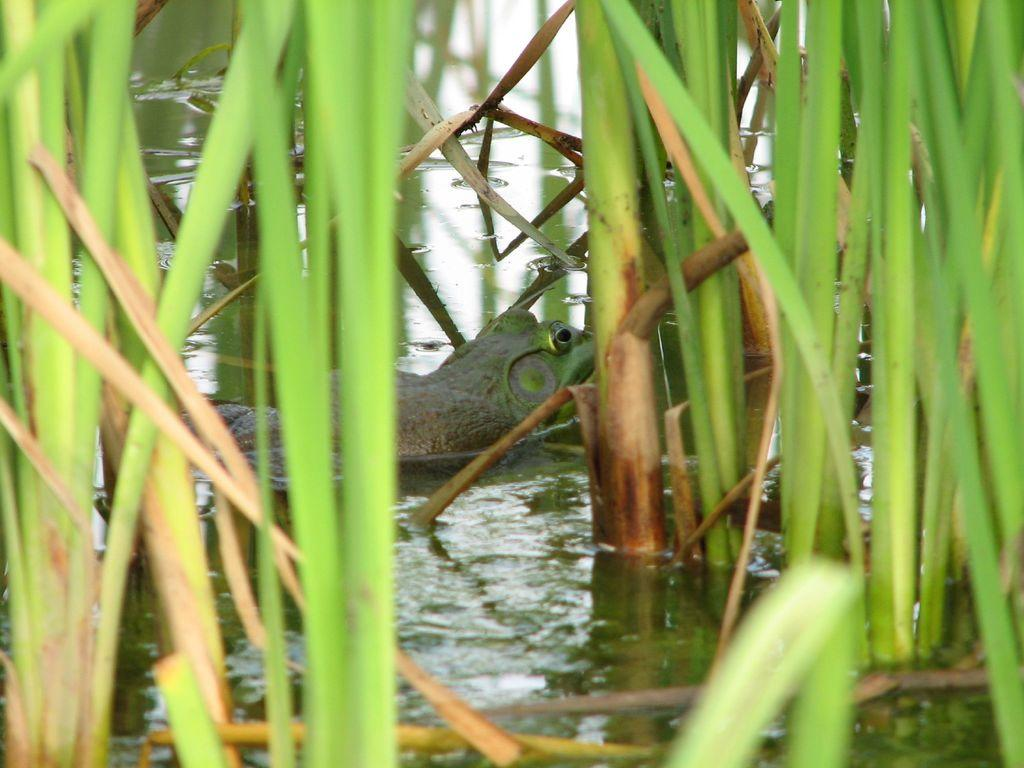What type of animal can be seen in the water in the image? There is an animal in the water in the image, but the specific type cannot be determined from the facts provided. What can be seen in the background of the image? There is a group of plants in the background of the image. In which direction is the animal in the water swimming in the image? The direction in which the animal is swimming cannot be determined from the facts provided, as the specific type of animal and its swimming direction are not mentioned. What type of root system do the plants in the background have? The type of root system the plants in the background have cannot be determined from the facts provided, as the specific type of plants and their root systems are not mentioned. 